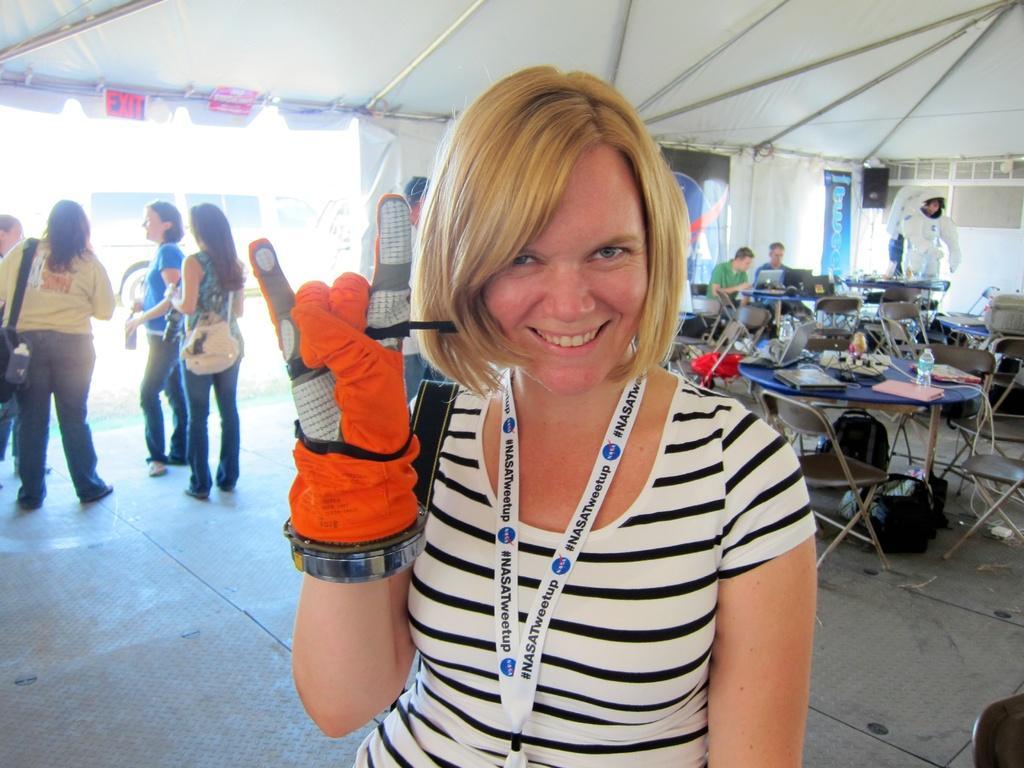Could you give a brief overview of what you see in this image? As we can see in the image there are few people here and there and there are chairs and tables. On tables there are files, bottles and projector. 